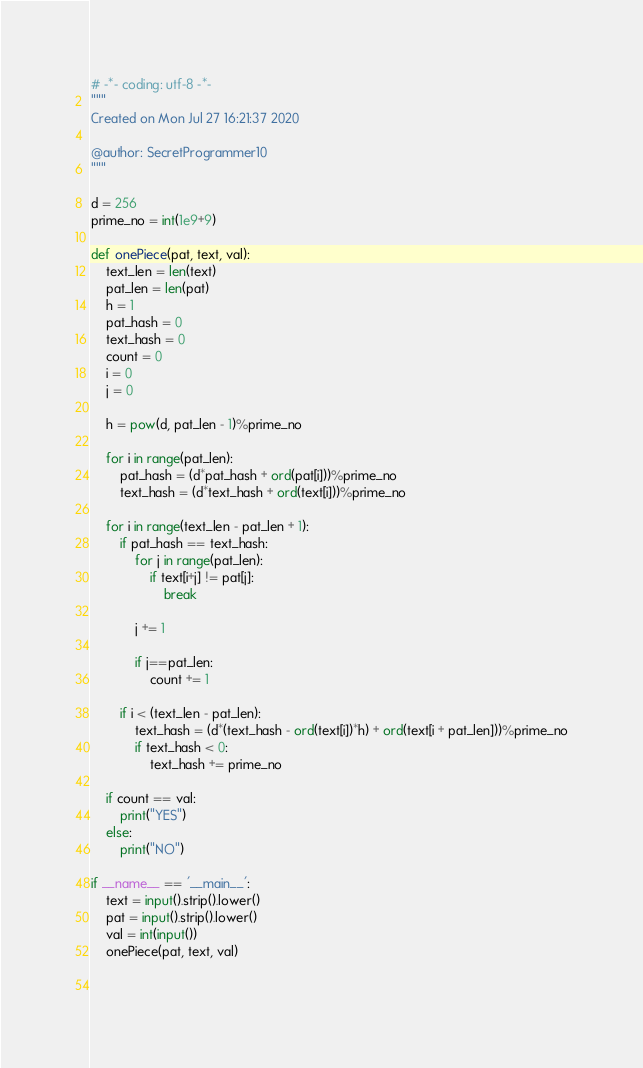Convert code to text. <code><loc_0><loc_0><loc_500><loc_500><_Python_># -*- coding: utf-8 -*-
"""
Created on Mon Jul 27 16:21:37 2020

@author: SecretProgrammer10
"""

d = 256
prime_no = int(1e9+9)

def onePiece(pat, text, val):
    text_len = len(text)
    pat_len = len(pat)
    h = 1
    pat_hash = 0
    text_hash = 0
    count = 0
    i = 0
    j = 0
    
    h = pow(d, pat_len - 1)%prime_no
    
    for i in range(pat_len):
        pat_hash = (d*pat_hash + ord(pat[i]))%prime_no
        text_hash = (d*text_hash + ord(text[i]))%prime_no
    
    for i in range(text_len - pat_len + 1):
        if pat_hash == text_hash:
            for j in range(pat_len):
                if text[i+j] != pat[j]:
                    break
            
            j += 1
            
            if j==pat_len:
                count += 1
            
        if i < (text_len - pat_len):
            text_hash = (d*(text_hash - ord(text[i])*h) + ord(text[i + pat_len]))%prime_no
            if text_hash < 0:
                text_hash += prime_no
    
    if count == val:
        print("YES")
    else:
        print("NO")

if __name__ == '__main__':
    text = input().strip().lower()
    pat = input().strip().lower()
    val = int(input())
    onePiece(pat, text, val)

                
</code> 